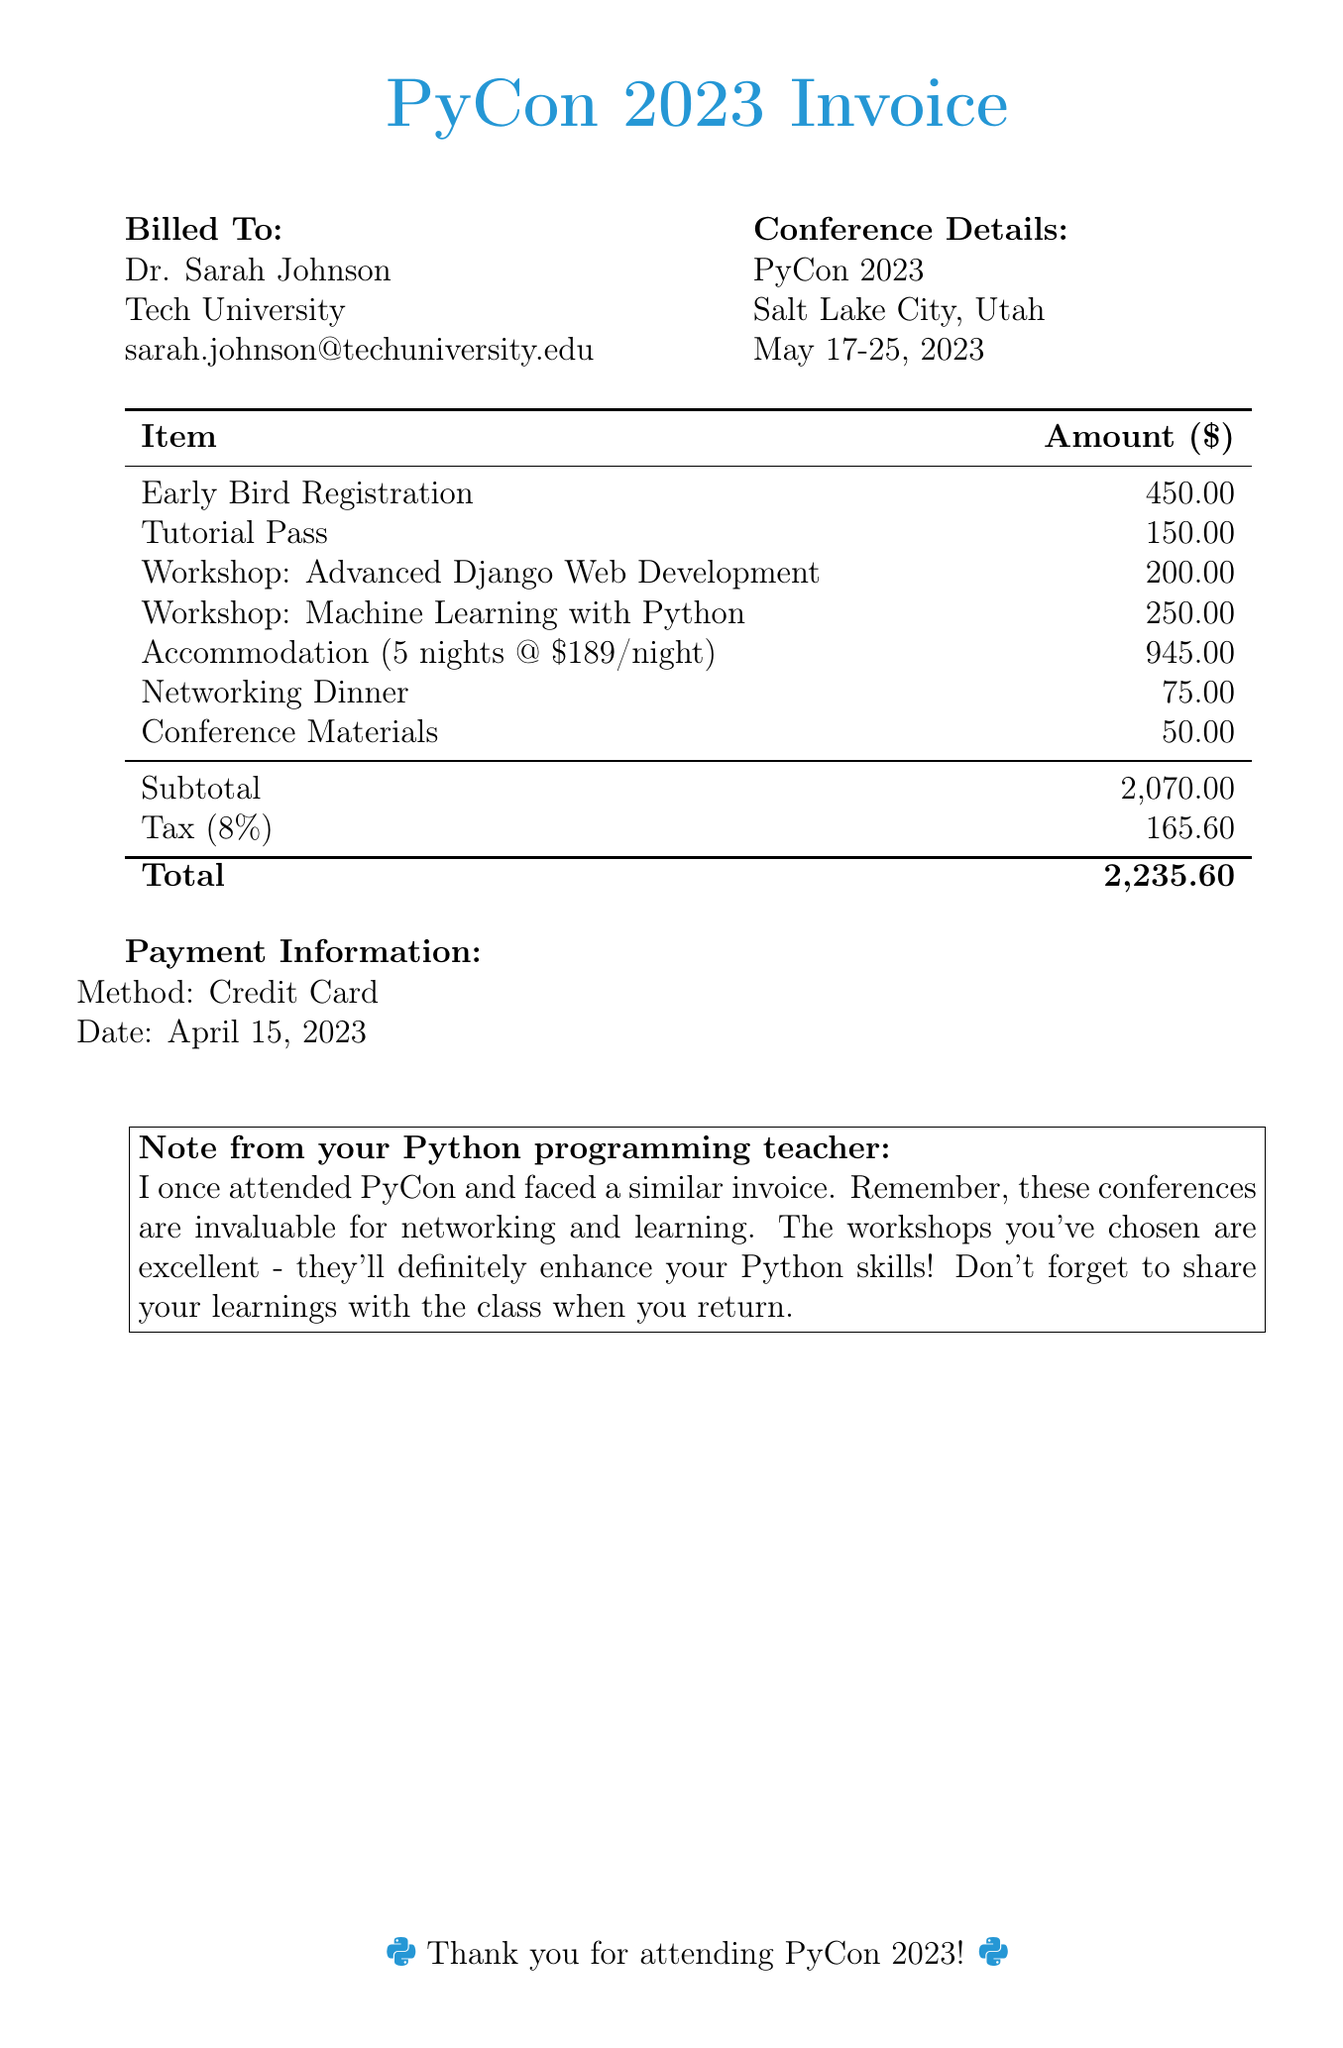What is the billed amount for early bird registration? The billed amount for early bird registration is directly listed in the invoice as $450.00.
Answer: $450.00 Who is the invoice billed to? The invoice specifies that it is billed to Dr. Sarah Johnson.
Answer: Dr. Sarah Johnson What is the total amount due? The total amount due is clearly indicated at the bottom of the invoice as $2,235.60.
Answer: $2,235.60 How many nights of accommodation were charged? The invoice states that accommodation for 5 nights was charged at a specified rate.
Answer: 5 nights What workshops were included in the invoice? The invoice lists two workshops: Advanced Django Web Development and Machine Learning with Python.
Answer: Advanced Django Web Development and Machine Learning with Python What is the date of the conference? The date of the conference is provided in the details as May 17-25, 2023.
Answer: May 17-25, 2023 How much was charged for tax? The invoice includes a tax charge that totals $165.60.
Answer: $165.60 What payment method was used? The payment method specified in the invoice is Credit Card.
Answer: Credit Card What is the total charge for the accommodation? The total charge for accommodation is calculated as 5 nights at $189 per night, which equals $945.00.
Answer: $945.00 